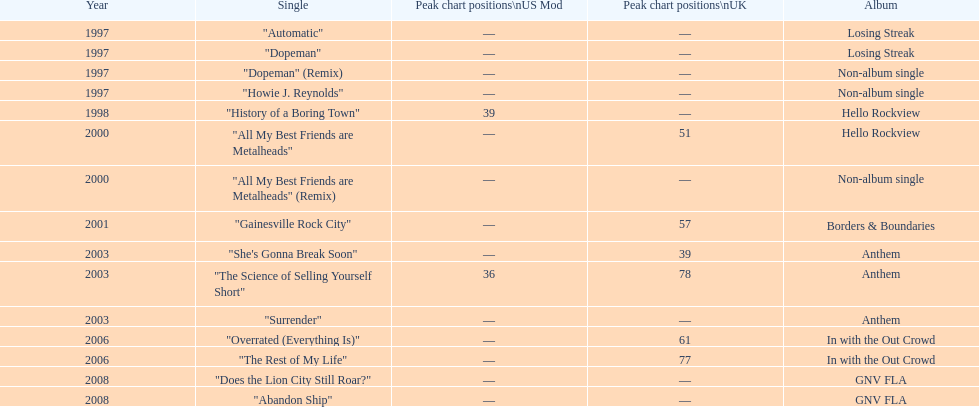How long was it between losing streak almbum and gnv fla in years. 11. 